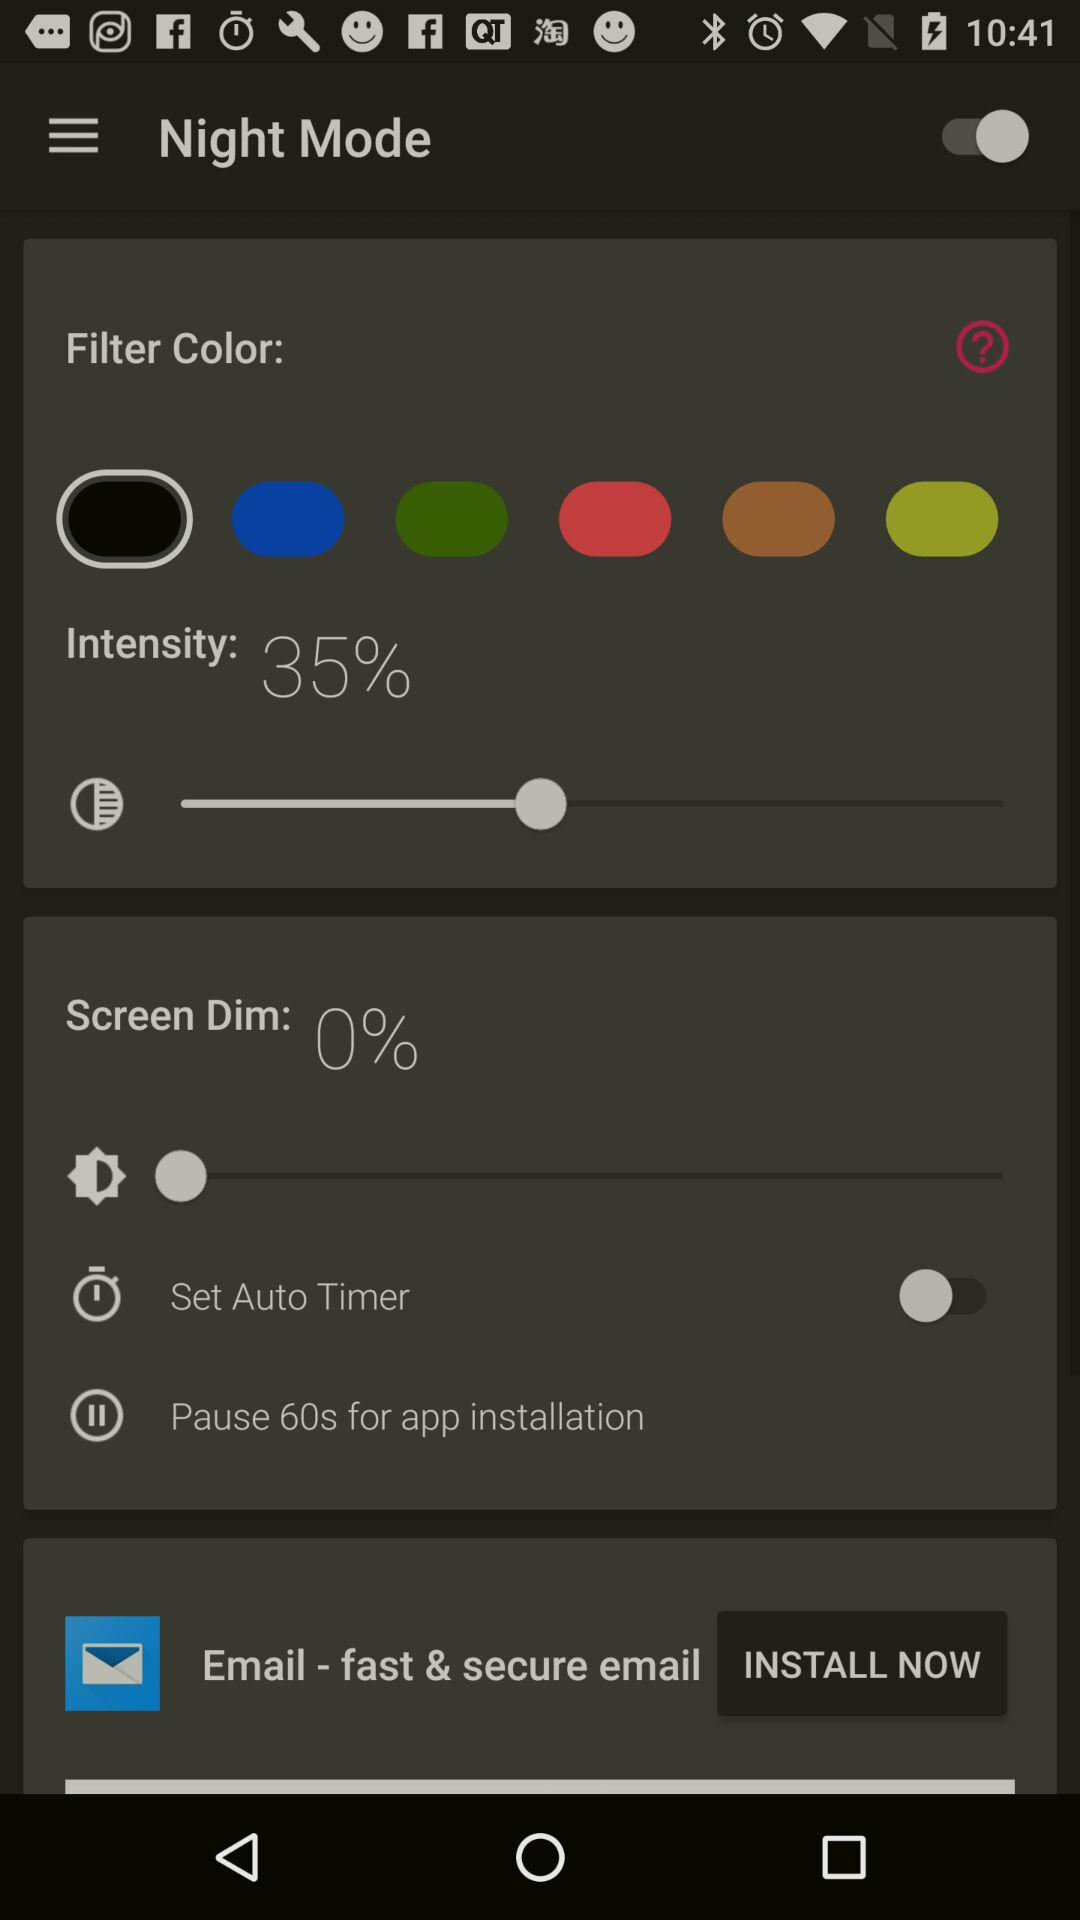What is the percentage of intensity? The percentage of intensity is 35. 